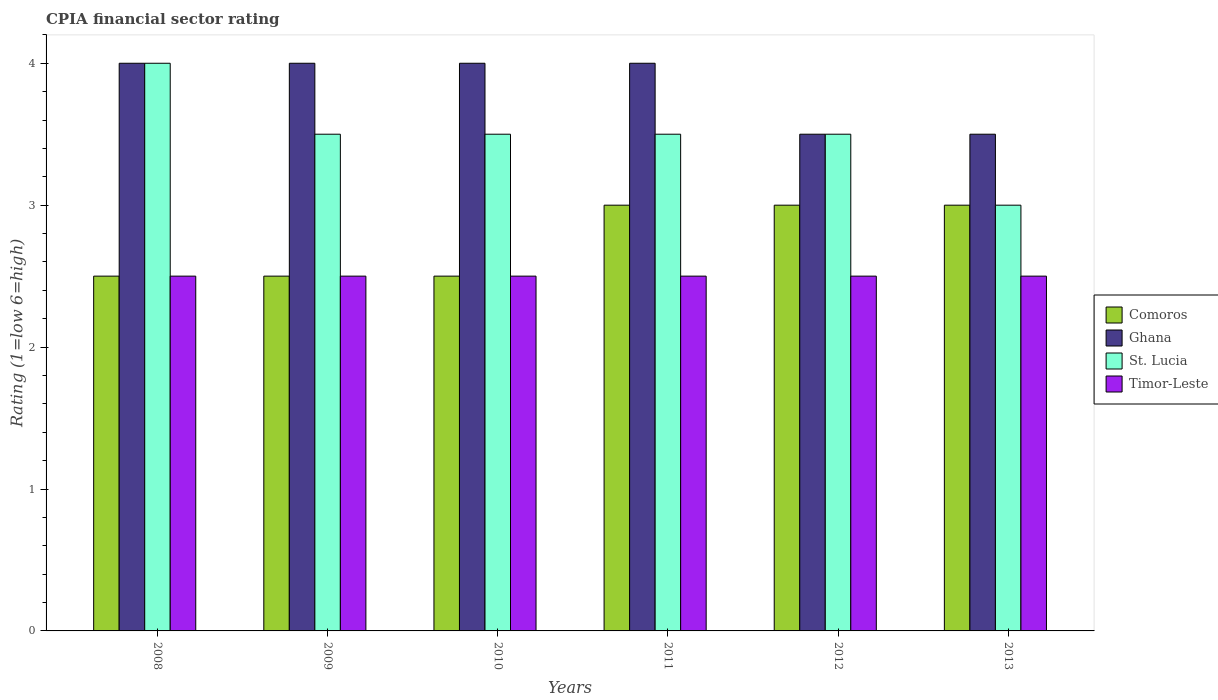How many different coloured bars are there?
Make the answer very short. 4. How many groups of bars are there?
Ensure brevity in your answer.  6. How many bars are there on the 5th tick from the left?
Make the answer very short. 4. How many bars are there on the 3rd tick from the right?
Provide a short and direct response. 4. What is the CPIA rating in Ghana in 2012?
Provide a succinct answer. 3.5. What is the difference between the CPIA rating in St. Lucia in 2008 and that in 2010?
Provide a succinct answer. 0.5. What is the difference between the CPIA rating in Comoros in 2011 and the CPIA rating in Ghana in 2012?
Your answer should be very brief. -0.5. In the year 2009, what is the difference between the CPIA rating in Ghana and CPIA rating in Timor-Leste?
Keep it short and to the point. 1.5. What is the ratio of the CPIA rating in Ghana in 2011 to that in 2013?
Ensure brevity in your answer.  1.14. Is the CPIA rating in Timor-Leste in 2008 less than that in 2009?
Your answer should be very brief. No. Is the difference between the CPIA rating in Ghana in 2010 and 2012 greater than the difference between the CPIA rating in Timor-Leste in 2010 and 2012?
Give a very brief answer. Yes. What is the difference between the highest and the lowest CPIA rating in St. Lucia?
Provide a short and direct response. 1. In how many years, is the CPIA rating in Ghana greater than the average CPIA rating in Ghana taken over all years?
Ensure brevity in your answer.  4. Is it the case that in every year, the sum of the CPIA rating in St. Lucia and CPIA rating in Ghana is greater than the sum of CPIA rating in Comoros and CPIA rating in Timor-Leste?
Ensure brevity in your answer.  Yes. What does the 4th bar from the left in 2009 represents?
Offer a terse response. Timor-Leste. Is it the case that in every year, the sum of the CPIA rating in Ghana and CPIA rating in Timor-Leste is greater than the CPIA rating in Comoros?
Offer a very short reply. Yes. How many bars are there?
Give a very brief answer. 24. Are all the bars in the graph horizontal?
Keep it short and to the point. No. How many years are there in the graph?
Provide a succinct answer. 6. What is the difference between two consecutive major ticks on the Y-axis?
Ensure brevity in your answer.  1. How many legend labels are there?
Give a very brief answer. 4. How are the legend labels stacked?
Your answer should be compact. Vertical. What is the title of the graph?
Your response must be concise. CPIA financial sector rating. Does "Pacific island small states" appear as one of the legend labels in the graph?
Your answer should be compact. No. What is the label or title of the X-axis?
Provide a short and direct response. Years. What is the Rating (1=low 6=high) in Comoros in 2008?
Your answer should be compact. 2.5. What is the Rating (1=low 6=high) in St. Lucia in 2008?
Give a very brief answer. 4. What is the Rating (1=low 6=high) in Timor-Leste in 2010?
Keep it short and to the point. 2.5. What is the Rating (1=low 6=high) in Comoros in 2012?
Keep it short and to the point. 3. What is the Rating (1=low 6=high) of Ghana in 2012?
Your response must be concise. 3.5. What is the Rating (1=low 6=high) of Timor-Leste in 2012?
Provide a succinct answer. 2.5. What is the Rating (1=low 6=high) of Timor-Leste in 2013?
Your response must be concise. 2.5. Across all years, what is the maximum Rating (1=low 6=high) in Comoros?
Your answer should be very brief. 3. Across all years, what is the minimum Rating (1=low 6=high) of Ghana?
Your response must be concise. 3.5. What is the total Rating (1=low 6=high) of Ghana in the graph?
Ensure brevity in your answer.  23. What is the total Rating (1=low 6=high) of St. Lucia in the graph?
Provide a short and direct response. 21. What is the total Rating (1=low 6=high) of Timor-Leste in the graph?
Keep it short and to the point. 15. What is the difference between the Rating (1=low 6=high) in Comoros in 2008 and that in 2009?
Offer a terse response. 0. What is the difference between the Rating (1=low 6=high) in St. Lucia in 2008 and that in 2009?
Provide a succinct answer. 0.5. What is the difference between the Rating (1=low 6=high) in Timor-Leste in 2008 and that in 2009?
Your answer should be very brief. 0. What is the difference between the Rating (1=low 6=high) in Comoros in 2008 and that in 2010?
Provide a short and direct response. 0. What is the difference between the Rating (1=low 6=high) of Ghana in 2008 and that in 2010?
Your answer should be compact. 0. What is the difference between the Rating (1=low 6=high) of St. Lucia in 2008 and that in 2010?
Your response must be concise. 0.5. What is the difference between the Rating (1=low 6=high) in Comoros in 2008 and that in 2011?
Offer a very short reply. -0.5. What is the difference between the Rating (1=low 6=high) of St. Lucia in 2008 and that in 2011?
Your answer should be very brief. 0.5. What is the difference between the Rating (1=low 6=high) in Comoros in 2008 and that in 2012?
Offer a very short reply. -0.5. What is the difference between the Rating (1=low 6=high) of Ghana in 2008 and that in 2012?
Your answer should be very brief. 0.5. What is the difference between the Rating (1=low 6=high) in Timor-Leste in 2008 and that in 2012?
Ensure brevity in your answer.  0. What is the difference between the Rating (1=low 6=high) in St. Lucia in 2008 and that in 2013?
Offer a terse response. 1. What is the difference between the Rating (1=low 6=high) in Ghana in 2009 and that in 2010?
Give a very brief answer. 0. What is the difference between the Rating (1=low 6=high) of St. Lucia in 2009 and that in 2010?
Provide a succinct answer. 0. What is the difference between the Rating (1=low 6=high) in Timor-Leste in 2009 and that in 2010?
Offer a terse response. 0. What is the difference between the Rating (1=low 6=high) in Ghana in 2009 and that in 2011?
Provide a succinct answer. 0. What is the difference between the Rating (1=low 6=high) of Timor-Leste in 2009 and that in 2011?
Your response must be concise. 0. What is the difference between the Rating (1=low 6=high) of Comoros in 2009 and that in 2012?
Ensure brevity in your answer.  -0.5. What is the difference between the Rating (1=low 6=high) of Ghana in 2009 and that in 2012?
Provide a short and direct response. 0.5. What is the difference between the Rating (1=low 6=high) in St. Lucia in 2009 and that in 2012?
Offer a very short reply. 0. What is the difference between the Rating (1=low 6=high) in Timor-Leste in 2009 and that in 2012?
Offer a terse response. 0. What is the difference between the Rating (1=low 6=high) in Comoros in 2009 and that in 2013?
Offer a very short reply. -0.5. What is the difference between the Rating (1=low 6=high) of Ghana in 2009 and that in 2013?
Provide a short and direct response. 0.5. What is the difference between the Rating (1=low 6=high) in Comoros in 2010 and that in 2011?
Your answer should be very brief. -0.5. What is the difference between the Rating (1=low 6=high) of Ghana in 2010 and that in 2011?
Keep it short and to the point. 0. What is the difference between the Rating (1=low 6=high) in St. Lucia in 2010 and that in 2011?
Make the answer very short. 0. What is the difference between the Rating (1=low 6=high) in Timor-Leste in 2010 and that in 2011?
Offer a very short reply. 0. What is the difference between the Rating (1=low 6=high) in Comoros in 2010 and that in 2012?
Your answer should be compact. -0.5. What is the difference between the Rating (1=low 6=high) in St. Lucia in 2010 and that in 2012?
Your response must be concise. 0. What is the difference between the Rating (1=low 6=high) of Timor-Leste in 2010 and that in 2012?
Your response must be concise. 0. What is the difference between the Rating (1=low 6=high) of St. Lucia in 2010 and that in 2013?
Your answer should be very brief. 0.5. What is the difference between the Rating (1=low 6=high) of Timor-Leste in 2010 and that in 2013?
Offer a very short reply. 0. What is the difference between the Rating (1=low 6=high) of Comoros in 2011 and that in 2012?
Provide a short and direct response. 0. What is the difference between the Rating (1=low 6=high) in St. Lucia in 2011 and that in 2012?
Offer a very short reply. 0. What is the difference between the Rating (1=low 6=high) of Timor-Leste in 2011 and that in 2013?
Your answer should be compact. 0. What is the difference between the Rating (1=low 6=high) of Comoros in 2012 and that in 2013?
Ensure brevity in your answer.  0. What is the difference between the Rating (1=low 6=high) in Comoros in 2008 and the Rating (1=low 6=high) in St. Lucia in 2009?
Make the answer very short. -1. What is the difference between the Rating (1=low 6=high) of Comoros in 2008 and the Rating (1=low 6=high) of Timor-Leste in 2009?
Your response must be concise. 0. What is the difference between the Rating (1=low 6=high) in Ghana in 2008 and the Rating (1=low 6=high) in Timor-Leste in 2009?
Your answer should be very brief. 1.5. What is the difference between the Rating (1=low 6=high) of Comoros in 2008 and the Rating (1=low 6=high) of Ghana in 2010?
Make the answer very short. -1.5. What is the difference between the Rating (1=low 6=high) in Ghana in 2008 and the Rating (1=low 6=high) in St. Lucia in 2010?
Provide a succinct answer. 0.5. What is the difference between the Rating (1=low 6=high) of Ghana in 2008 and the Rating (1=low 6=high) of Timor-Leste in 2010?
Your answer should be very brief. 1.5. What is the difference between the Rating (1=low 6=high) of St. Lucia in 2008 and the Rating (1=low 6=high) of Timor-Leste in 2010?
Your response must be concise. 1.5. What is the difference between the Rating (1=low 6=high) in Comoros in 2008 and the Rating (1=low 6=high) in St. Lucia in 2011?
Offer a very short reply. -1. What is the difference between the Rating (1=low 6=high) in Ghana in 2008 and the Rating (1=low 6=high) in St. Lucia in 2011?
Your answer should be compact. 0.5. What is the difference between the Rating (1=low 6=high) in Ghana in 2008 and the Rating (1=low 6=high) in Timor-Leste in 2011?
Make the answer very short. 1.5. What is the difference between the Rating (1=low 6=high) of St. Lucia in 2008 and the Rating (1=low 6=high) of Timor-Leste in 2011?
Offer a very short reply. 1.5. What is the difference between the Rating (1=low 6=high) of Comoros in 2008 and the Rating (1=low 6=high) of Ghana in 2012?
Provide a succinct answer. -1. What is the difference between the Rating (1=low 6=high) of Comoros in 2008 and the Rating (1=low 6=high) of St. Lucia in 2012?
Give a very brief answer. -1. What is the difference between the Rating (1=low 6=high) of Comoros in 2008 and the Rating (1=low 6=high) of Timor-Leste in 2012?
Ensure brevity in your answer.  0. What is the difference between the Rating (1=low 6=high) of Comoros in 2008 and the Rating (1=low 6=high) of Ghana in 2013?
Your response must be concise. -1. What is the difference between the Rating (1=low 6=high) of Comoros in 2008 and the Rating (1=low 6=high) of St. Lucia in 2013?
Your answer should be compact. -0.5. What is the difference between the Rating (1=low 6=high) in Ghana in 2008 and the Rating (1=low 6=high) in St. Lucia in 2013?
Your answer should be compact. 1. What is the difference between the Rating (1=low 6=high) of Ghana in 2008 and the Rating (1=low 6=high) of Timor-Leste in 2013?
Your response must be concise. 1.5. What is the difference between the Rating (1=low 6=high) in Ghana in 2009 and the Rating (1=low 6=high) in St. Lucia in 2010?
Provide a succinct answer. 0.5. What is the difference between the Rating (1=low 6=high) in Ghana in 2009 and the Rating (1=low 6=high) in Timor-Leste in 2010?
Your response must be concise. 1.5. What is the difference between the Rating (1=low 6=high) of Comoros in 2009 and the Rating (1=low 6=high) of St. Lucia in 2011?
Your answer should be very brief. -1. What is the difference between the Rating (1=low 6=high) of Comoros in 2009 and the Rating (1=low 6=high) of Timor-Leste in 2011?
Your answer should be very brief. 0. What is the difference between the Rating (1=low 6=high) in Ghana in 2009 and the Rating (1=low 6=high) in St. Lucia in 2011?
Your answer should be compact. 0.5. What is the difference between the Rating (1=low 6=high) in Comoros in 2009 and the Rating (1=low 6=high) in Timor-Leste in 2012?
Your answer should be very brief. 0. What is the difference between the Rating (1=low 6=high) of Ghana in 2009 and the Rating (1=low 6=high) of St. Lucia in 2012?
Keep it short and to the point. 0.5. What is the difference between the Rating (1=low 6=high) of Ghana in 2009 and the Rating (1=low 6=high) of Timor-Leste in 2012?
Offer a very short reply. 1.5. What is the difference between the Rating (1=low 6=high) of Ghana in 2009 and the Rating (1=low 6=high) of St. Lucia in 2013?
Make the answer very short. 1. What is the difference between the Rating (1=low 6=high) of Comoros in 2010 and the Rating (1=low 6=high) of Ghana in 2011?
Make the answer very short. -1.5. What is the difference between the Rating (1=low 6=high) in Comoros in 2010 and the Rating (1=low 6=high) in St. Lucia in 2011?
Your answer should be very brief. -1. What is the difference between the Rating (1=low 6=high) in Ghana in 2010 and the Rating (1=low 6=high) in Timor-Leste in 2011?
Your answer should be very brief. 1.5. What is the difference between the Rating (1=low 6=high) in Comoros in 2010 and the Rating (1=low 6=high) in St. Lucia in 2012?
Give a very brief answer. -1. What is the difference between the Rating (1=low 6=high) of Ghana in 2010 and the Rating (1=low 6=high) of St. Lucia in 2012?
Offer a terse response. 0.5. What is the difference between the Rating (1=low 6=high) of St. Lucia in 2010 and the Rating (1=low 6=high) of Timor-Leste in 2012?
Provide a succinct answer. 1. What is the difference between the Rating (1=low 6=high) of Comoros in 2010 and the Rating (1=low 6=high) of Ghana in 2013?
Provide a short and direct response. -1. What is the difference between the Rating (1=low 6=high) of Comoros in 2010 and the Rating (1=low 6=high) of Timor-Leste in 2013?
Give a very brief answer. 0. What is the difference between the Rating (1=low 6=high) in St. Lucia in 2010 and the Rating (1=low 6=high) in Timor-Leste in 2013?
Offer a very short reply. 1. What is the difference between the Rating (1=low 6=high) of Comoros in 2011 and the Rating (1=low 6=high) of Ghana in 2012?
Your response must be concise. -0.5. What is the difference between the Rating (1=low 6=high) in St. Lucia in 2011 and the Rating (1=low 6=high) in Timor-Leste in 2012?
Your response must be concise. 1. What is the difference between the Rating (1=low 6=high) of Comoros in 2011 and the Rating (1=low 6=high) of St. Lucia in 2013?
Provide a short and direct response. 0. What is the difference between the Rating (1=low 6=high) of St. Lucia in 2011 and the Rating (1=low 6=high) of Timor-Leste in 2013?
Ensure brevity in your answer.  1. What is the difference between the Rating (1=low 6=high) of Comoros in 2012 and the Rating (1=low 6=high) of St. Lucia in 2013?
Keep it short and to the point. 0. What is the difference between the Rating (1=low 6=high) of Comoros in 2012 and the Rating (1=low 6=high) of Timor-Leste in 2013?
Your answer should be compact. 0.5. What is the difference between the Rating (1=low 6=high) of Ghana in 2012 and the Rating (1=low 6=high) of St. Lucia in 2013?
Provide a short and direct response. 0.5. What is the difference between the Rating (1=low 6=high) of Ghana in 2012 and the Rating (1=low 6=high) of Timor-Leste in 2013?
Give a very brief answer. 1. What is the difference between the Rating (1=low 6=high) in St. Lucia in 2012 and the Rating (1=low 6=high) in Timor-Leste in 2013?
Make the answer very short. 1. What is the average Rating (1=low 6=high) of Comoros per year?
Make the answer very short. 2.75. What is the average Rating (1=low 6=high) in Ghana per year?
Offer a very short reply. 3.83. What is the average Rating (1=low 6=high) in Timor-Leste per year?
Give a very brief answer. 2.5. In the year 2008, what is the difference between the Rating (1=low 6=high) in Comoros and Rating (1=low 6=high) in Ghana?
Your response must be concise. -1.5. In the year 2008, what is the difference between the Rating (1=low 6=high) in Comoros and Rating (1=low 6=high) in St. Lucia?
Keep it short and to the point. -1.5. In the year 2008, what is the difference between the Rating (1=low 6=high) of Comoros and Rating (1=low 6=high) of Timor-Leste?
Your answer should be very brief. 0. In the year 2008, what is the difference between the Rating (1=low 6=high) in Ghana and Rating (1=low 6=high) in Timor-Leste?
Ensure brevity in your answer.  1.5. In the year 2009, what is the difference between the Rating (1=low 6=high) of Comoros and Rating (1=low 6=high) of Ghana?
Offer a terse response. -1.5. In the year 2009, what is the difference between the Rating (1=low 6=high) in Comoros and Rating (1=low 6=high) in St. Lucia?
Give a very brief answer. -1. In the year 2009, what is the difference between the Rating (1=low 6=high) of Ghana and Rating (1=low 6=high) of Timor-Leste?
Provide a succinct answer. 1.5. In the year 2009, what is the difference between the Rating (1=low 6=high) in St. Lucia and Rating (1=low 6=high) in Timor-Leste?
Provide a succinct answer. 1. In the year 2010, what is the difference between the Rating (1=low 6=high) in Comoros and Rating (1=low 6=high) in Ghana?
Your response must be concise. -1.5. In the year 2010, what is the difference between the Rating (1=low 6=high) of Comoros and Rating (1=low 6=high) of St. Lucia?
Keep it short and to the point. -1. In the year 2010, what is the difference between the Rating (1=low 6=high) of Comoros and Rating (1=low 6=high) of Timor-Leste?
Make the answer very short. 0. In the year 2010, what is the difference between the Rating (1=low 6=high) in Ghana and Rating (1=low 6=high) in St. Lucia?
Make the answer very short. 0.5. In the year 2010, what is the difference between the Rating (1=low 6=high) of St. Lucia and Rating (1=low 6=high) of Timor-Leste?
Keep it short and to the point. 1. In the year 2012, what is the difference between the Rating (1=low 6=high) in Comoros and Rating (1=low 6=high) in St. Lucia?
Make the answer very short. -0.5. In the year 2012, what is the difference between the Rating (1=low 6=high) of St. Lucia and Rating (1=low 6=high) of Timor-Leste?
Keep it short and to the point. 1. In the year 2013, what is the difference between the Rating (1=low 6=high) in Comoros and Rating (1=low 6=high) in St. Lucia?
Ensure brevity in your answer.  0. In the year 2013, what is the difference between the Rating (1=low 6=high) in Comoros and Rating (1=low 6=high) in Timor-Leste?
Ensure brevity in your answer.  0.5. In the year 2013, what is the difference between the Rating (1=low 6=high) in Ghana and Rating (1=low 6=high) in St. Lucia?
Offer a very short reply. 0.5. In the year 2013, what is the difference between the Rating (1=low 6=high) in Ghana and Rating (1=low 6=high) in Timor-Leste?
Your answer should be very brief. 1. In the year 2013, what is the difference between the Rating (1=low 6=high) of St. Lucia and Rating (1=low 6=high) of Timor-Leste?
Provide a succinct answer. 0.5. What is the ratio of the Rating (1=low 6=high) in St. Lucia in 2008 to that in 2009?
Offer a very short reply. 1.14. What is the ratio of the Rating (1=low 6=high) in Timor-Leste in 2008 to that in 2009?
Offer a very short reply. 1. What is the ratio of the Rating (1=low 6=high) in Ghana in 2008 to that in 2010?
Make the answer very short. 1. What is the ratio of the Rating (1=low 6=high) of Timor-Leste in 2008 to that in 2010?
Your answer should be compact. 1. What is the ratio of the Rating (1=low 6=high) of Ghana in 2008 to that in 2011?
Make the answer very short. 1. What is the ratio of the Rating (1=low 6=high) of St. Lucia in 2008 to that in 2011?
Provide a succinct answer. 1.14. What is the ratio of the Rating (1=low 6=high) in Comoros in 2008 to that in 2012?
Provide a succinct answer. 0.83. What is the ratio of the Rating (1=low 6=high) of Ghana in 2008 to that in 2012?
Give a very brief answer. 1.14. What is the ratio of the Rating (1=low 6=high) in Comoros in 2008 to that in 2013?
Offer a terse response. 0.83. What is the ratio of the Rating (1=low 6=high) of St. Lucia in 2008 to that in 2013?
Offer a terse response. 1.33. What is the ratio of the Rating (1=low 6=high) in Comoros in 2009 to that in 2010?
Your answer should be compact. 1. What is the ratio of the Rating (1=low 6=high) of St. Lucia in 2009 to that in 2010?
Offer a terse response. 1. What is the ratio of the Rating (1=low 6=high) in Comoros in 2009 to that in 2011?
Ensure brevity in your answer.  0.83. What is the ratio of the Rating (1=low 6=high) in Ghana in 2009 to that in 2011?
Keep it short and to the point. 1. What is the ratio of the Rating (1=low 6=high) in St. Lucia in 2009 to that in 2011?
Your response must be concise. 1. What is the ratio of the Rating (1=low 6=high) of Timor-Leste in 2009 to that in 2011?
Your answer should be compact. 1. What is the ratio of the Rating (1=low 6=high) in St. Lucia in 2009 to that in 2012?
Ensure brevity in your answer.  1. What is the ratio of the Rating (1=low 6=high) of Comoros in 2009 to that in 2013?
Your answer should be very brief. 0.83. What is the ratio of the Rating (1=low 6=high) in Ghana in 2009 to that in 2013?
Provide a short and direct response. 1.14. What is the ratio of the Rating (1=low 6=high) in Ghana in 2010 to that in 2011?
Your answer should be very brief. 1. What is the ratio of the Rating (1=low 6=high) in Comoros in 2010 to that in 2012?
Offer a terse response. 0.83. What is the ratio of the Rating (1=low 6=high) of St. Lucia in 2010 to that in 2012?
Offer a very short reply. 1. What is the ratio of the Rating (1=low 6=high) of Timor-Leste in 2010 to that in 2012?
Ensure brevity in your answer.  1. What is the ratio of the Rating (1=low 6=high) of Comoros in 2010 to that in 2013?
Your answer should be compact. 0.83. What is the ratio of the Rating (1=low 6=high) of Ghana in 2010 to that in 2013?
Make the answer very short. 1.14. What is the ratio of the Rating (1=low 6=high) in St. Lucia in 2010 to that in 2013?
Provide a short and direct response. 1.17. What is the ratio of the Rating (1=low 6=high) of Comoros in 2011 to that in 2012?
Give a very brief answer. 1. What is the ratio of the Rating (1=low 6=high) of Timor-Leste in 2011 to that in 2012?
Ensure brevity in your answer.  1. What is the ratio of the Rating (1=low 6=high) in Comoros in 2011 to that in 2013?
Offer a terse response. 1. What is the ratio of the Rating (1=low 6=high) of Ghana in 2011 to that in 2013?
Provide a short and direct response. 1.14. What is the ratio of the Rating (1=low 6=high) in Timor-Leste in 2011 to that in 2013?
Keep it short and to the point. 1. What is the ratio of the Rating (1=low 6=high) of Comoros in 2012 to that in 2013?
Your answer should be very brief. 1. What is the ratio of the Rating (1=low 6=high) of Ghana in 2012 to that in 2013?
Provide a short and direct response. 1. What is the ratio of the Rating (1=low 6=high) of St. Lucia in 2012 to that in 2013?
Offer a very short reply. 1.17. What is the ratio of the Rating (1=low 6=high) of Timor-Leste in 2012 to that in 2013?
Offer a very short reply. 1. What is the difference between the highest and the second highest Rating (1=low 6=high) in Comoros?
Offer a terse response. 0. What is the difference between the highest and the second highest Rating (1=low 6=high) of Ghana?
Keep it short and to the point. 0. What is the difference between the highest and the second highest Rating (1=low 6=high) in Timor-Leste?
Provide a succinct answer. 0. What is the difference between the highest and the lowest Rating (1=low 6=high) of Comoros?
Offer a terse response. 0.5. What is the difference between the highest and the lowest Rating (1=low 6=high) of St. Lucia?
Give a very brief answer. 1. What is the difference between the highest and the lowest Rating (1=low 6=high) of Timor-Leste?
Provide a succinct answer. 0. 